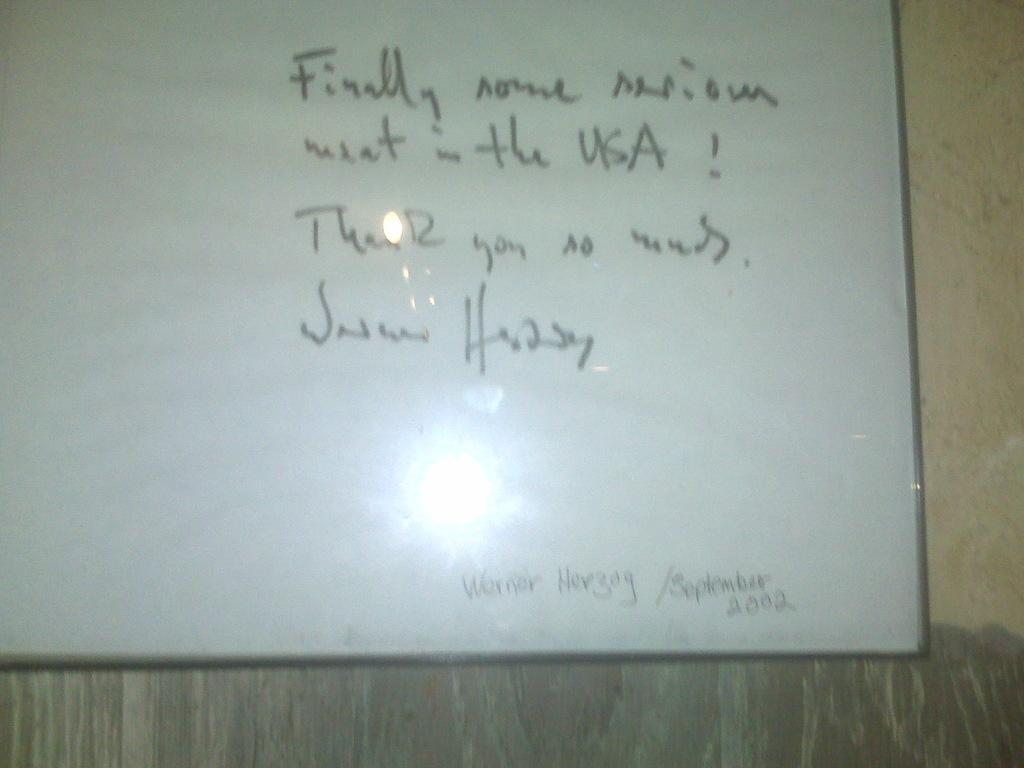<image>
Relay a brief, clear account of the picture shown. the date of September 2002 that is on a white board 